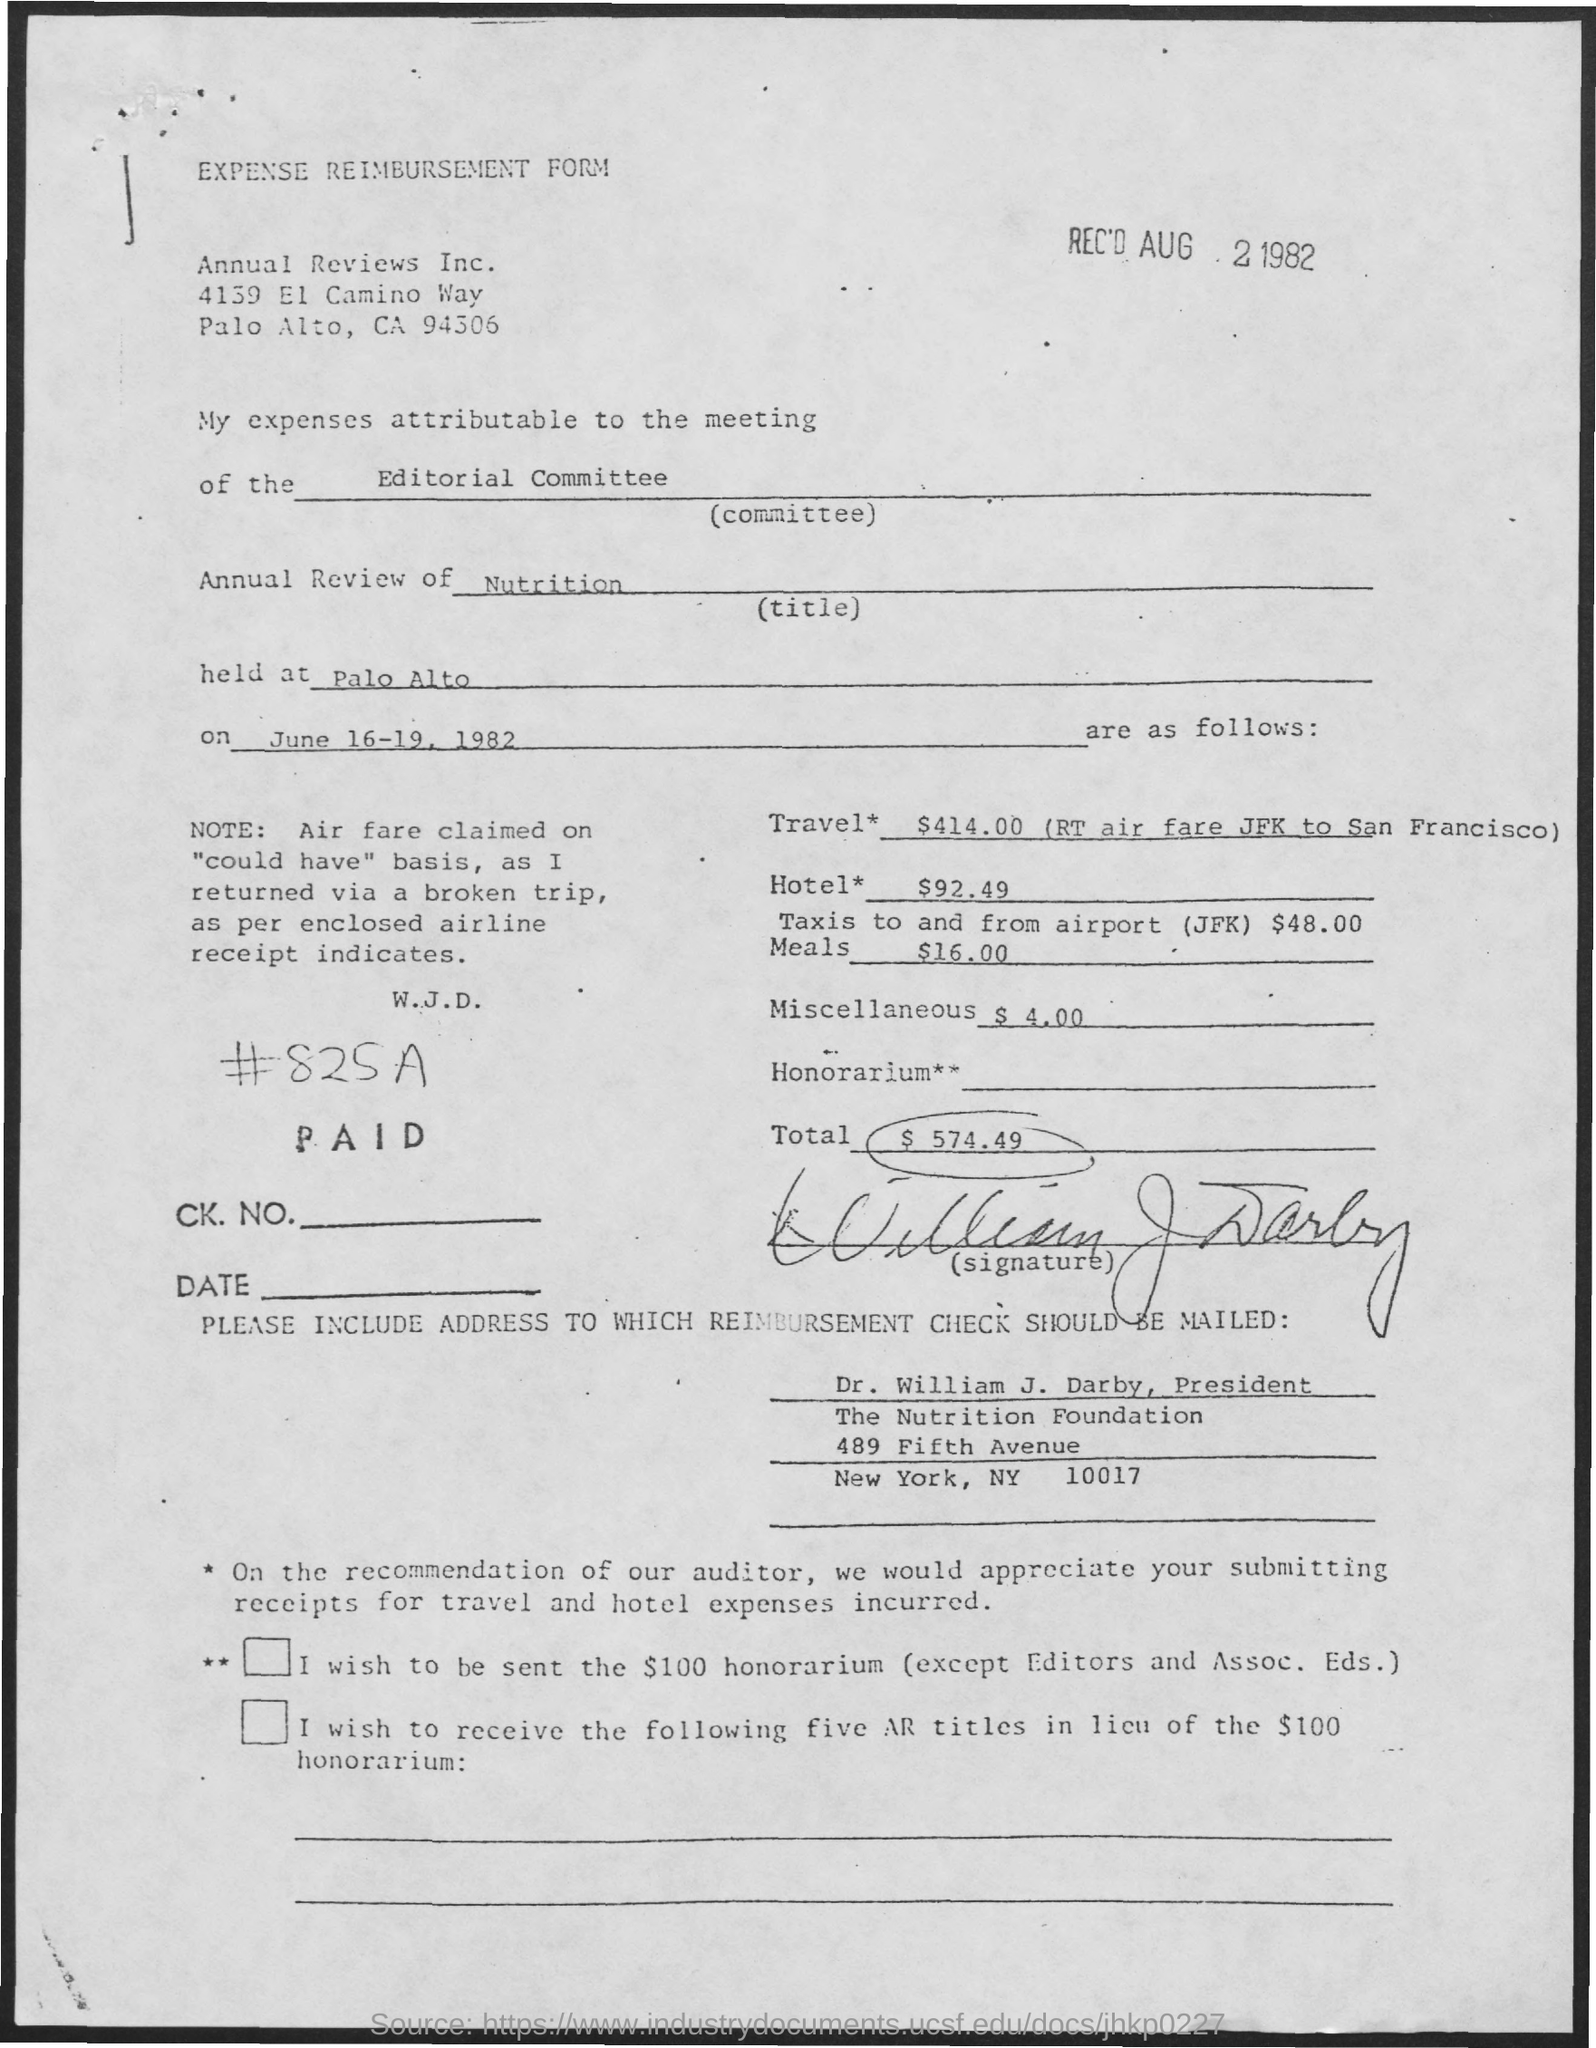What is the name of the form ?
Your answer should be very brief. EXPENSE REIMBURSEMENT FORM. On which date the form was received ?
Give a very brief answer. AUG 2 1982. WHAT IS THE NAME OF THE COMMITTEE MENTIONED IN THE GIVEN FORM ?
Offer a terse response. Editorial committee. Where was the meeting held ?
Make the answer very short. Palo Alto. On which dates the meetings was conducted ?
Make the answer very short. June 16-19 , 1982. What is the amount for travel mentioned in the given page ?
Make the answer very short. $414.00. What is the amount for hotel mentioned in the given page ?
Your answer should be very brief. 92.49. What is the amount for miscellaneous as mentioned in the given form ?
Offer a terse response. 4.00. What is the total amount mentioned in the given form ?
Provide a succinct answer. 574.49. 